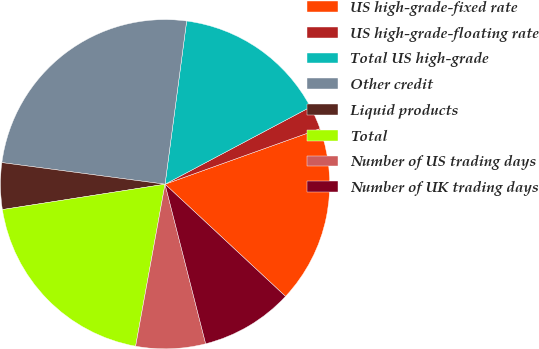Convert chart to OTSL. <chart><loc_0><loc_0><loc_500><loc_500><pie_chart><fcel>US high-grade-fixed rate<fcel>US high-grade-floating rate<fcel>Total US high-grade<fcel>Other credit<fcel>Liquid products<fcel>Total<fcel>Number of US trading days<fcel>Number of UK trading days<nl><fcel>17.41%<fcel>2.29%<fcel>15.14%<fcel>25.0%<fcel>4.56%<fcel>19.68%<fcel>6.83%<fcel>9.1%<nl></chart> 